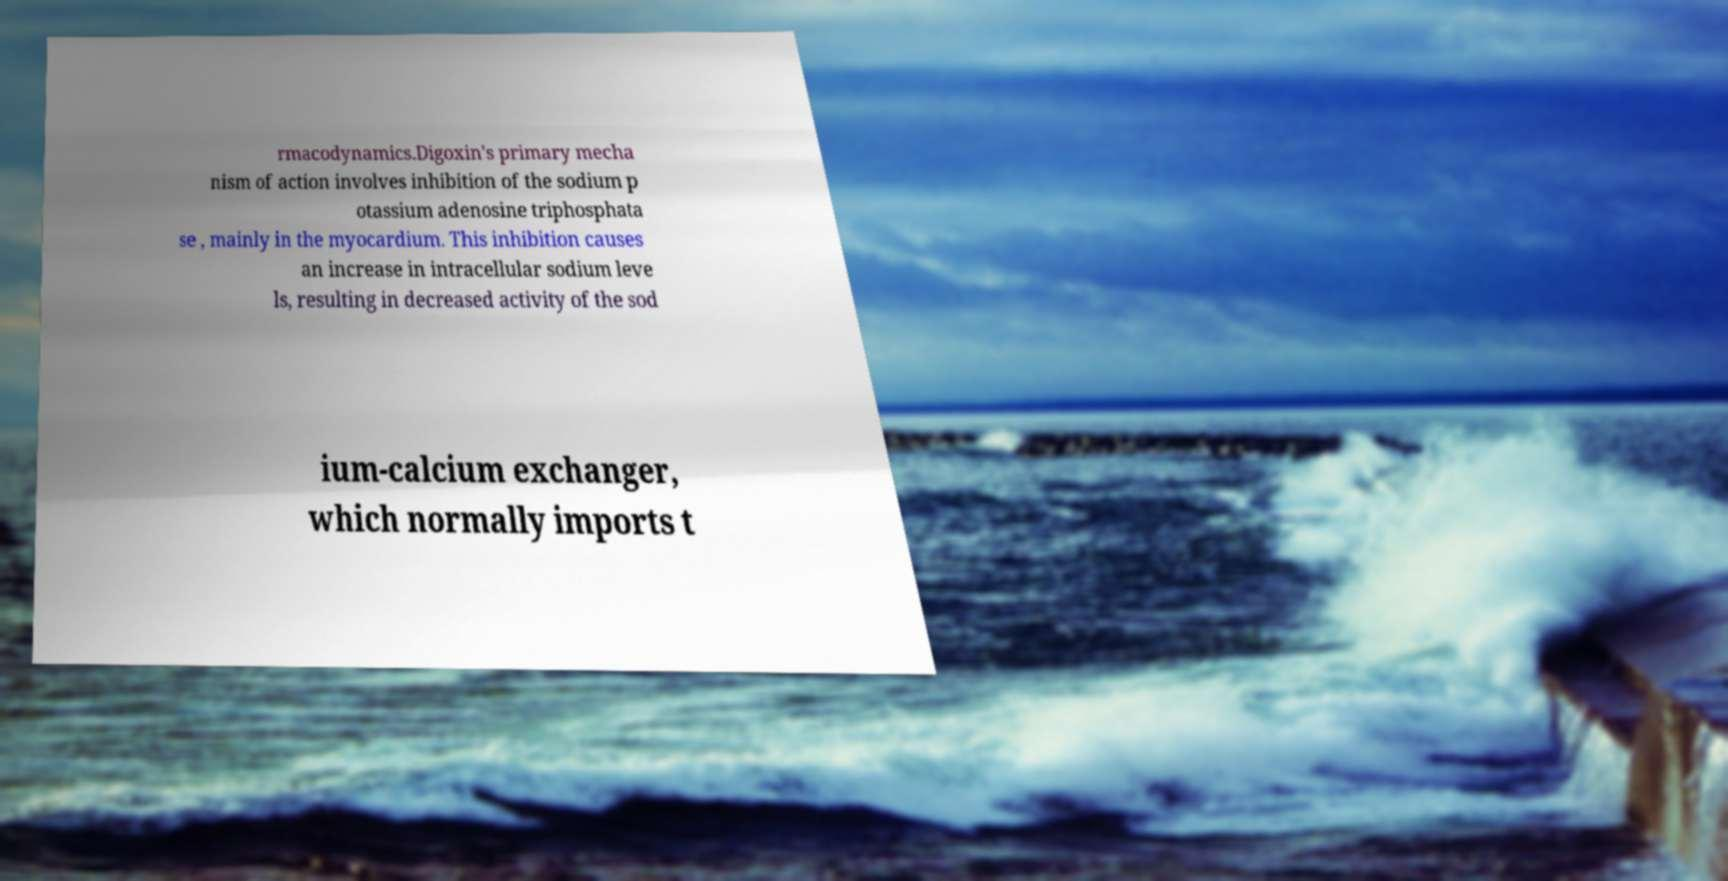Can you read and provide the text displayed in the image?This photo seems to have some interesting text. Can you extract and type it out for me? rmacodynamics.Digoxin's primary mecha nism of action involves inhibition of the sodium p otassium adenosine triphosphata se , mainly in the myocardium. This inhibition causes an increase in intracellular sodium leve ls, resulting in decreased activity of the sod ium-calcium exchanger, which normally imports t 